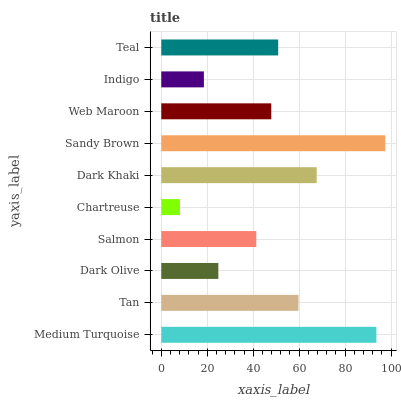Is Chartreuse the minimum?
Answer yes or no. Yes. Is Sandy Brown the maximum?
Answer yes or no. Yes. Is Tan the minimum?
Answer yes or no. No. Is Tan the maximum?
Answer yes or no. No. Is Medium Turquoise greater than Tan?
Answer yes or no. Yes. Is Tan less than Medium Turquoise?
Answer yes or no. Yes. Is Tan greater than Medium Turquoise?
Answer yes or no. No. Is Medium Turquoise less than Tan?
Answer yes or no. No. Is Teal the high median?
Answer yes or no. Yes. Is Web Maroon the low median?
Answer yes or no. Yes. Is Salmon the high median?
Answer yes or no. No. Is Dark Khaki the low median?
Answer yes or no. No. 